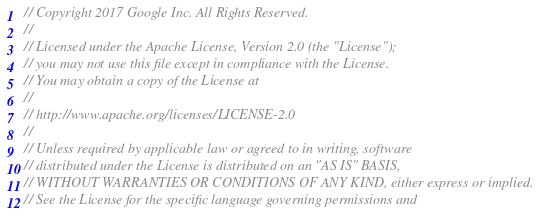<code> <loc_0><loc_0><loc_500><loc_500><_Java_>// Copyright 2017 Google Inc. All Rights Reserved.
//
// Licensed under the Apache License, Version 2.0 (the "License");
// you may not use this file except in compliance with the License.
// You may obtain a copy of the License at
//
// http://www.apache.org/licenses/LICENSE-2.0
//
// Unless required by applicable law or agreed to in writing, software
// distributed under the License is distributed on an "AS IS" BASIS,
// WITHOUT WARRANTIES OR CONDITIONS OF ANY KIND, either express or implied.
// See the License for the specific language governing permissions and</code> 